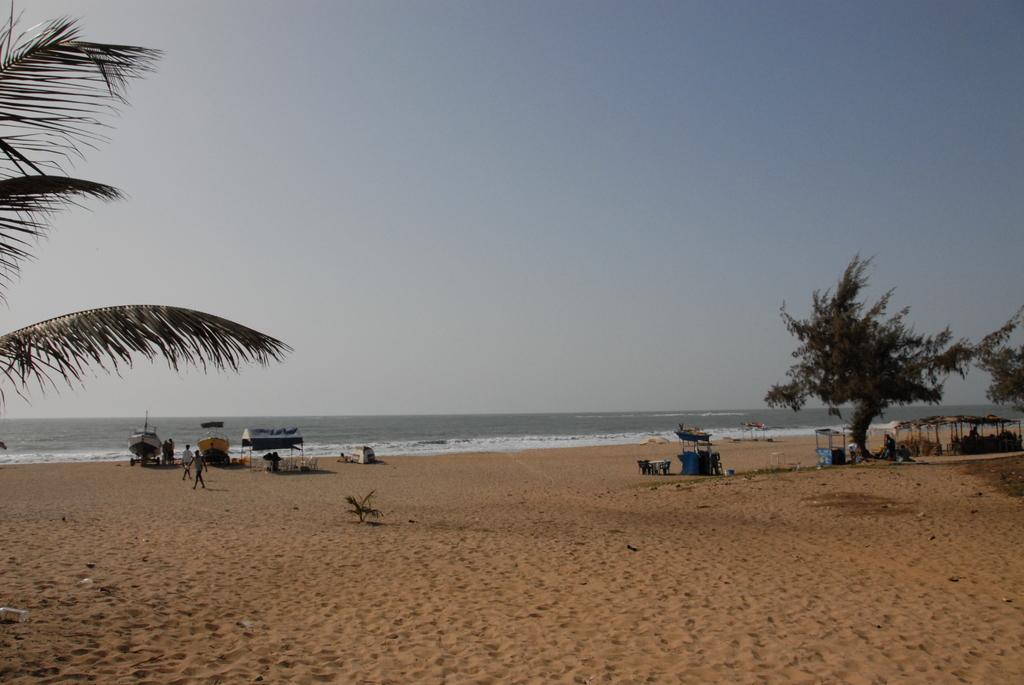What type of natural environment is depicted in the image? There is a beach in the front of the image. What can be seen on the sides of the image? Trees are present on either corner of the image. What are the boats doing in the middle of the image? The boats are on the shore in the middle of the image. What are the people in the image doing? There are people walking in the middle of the image. What is visible above the scene? The sky is visible above the scene. Where is the shop located in the image? There is no shop present in the image. What type of fruit is being washed by the people in the image? There is no fruit or washing activity depicted in the image. 